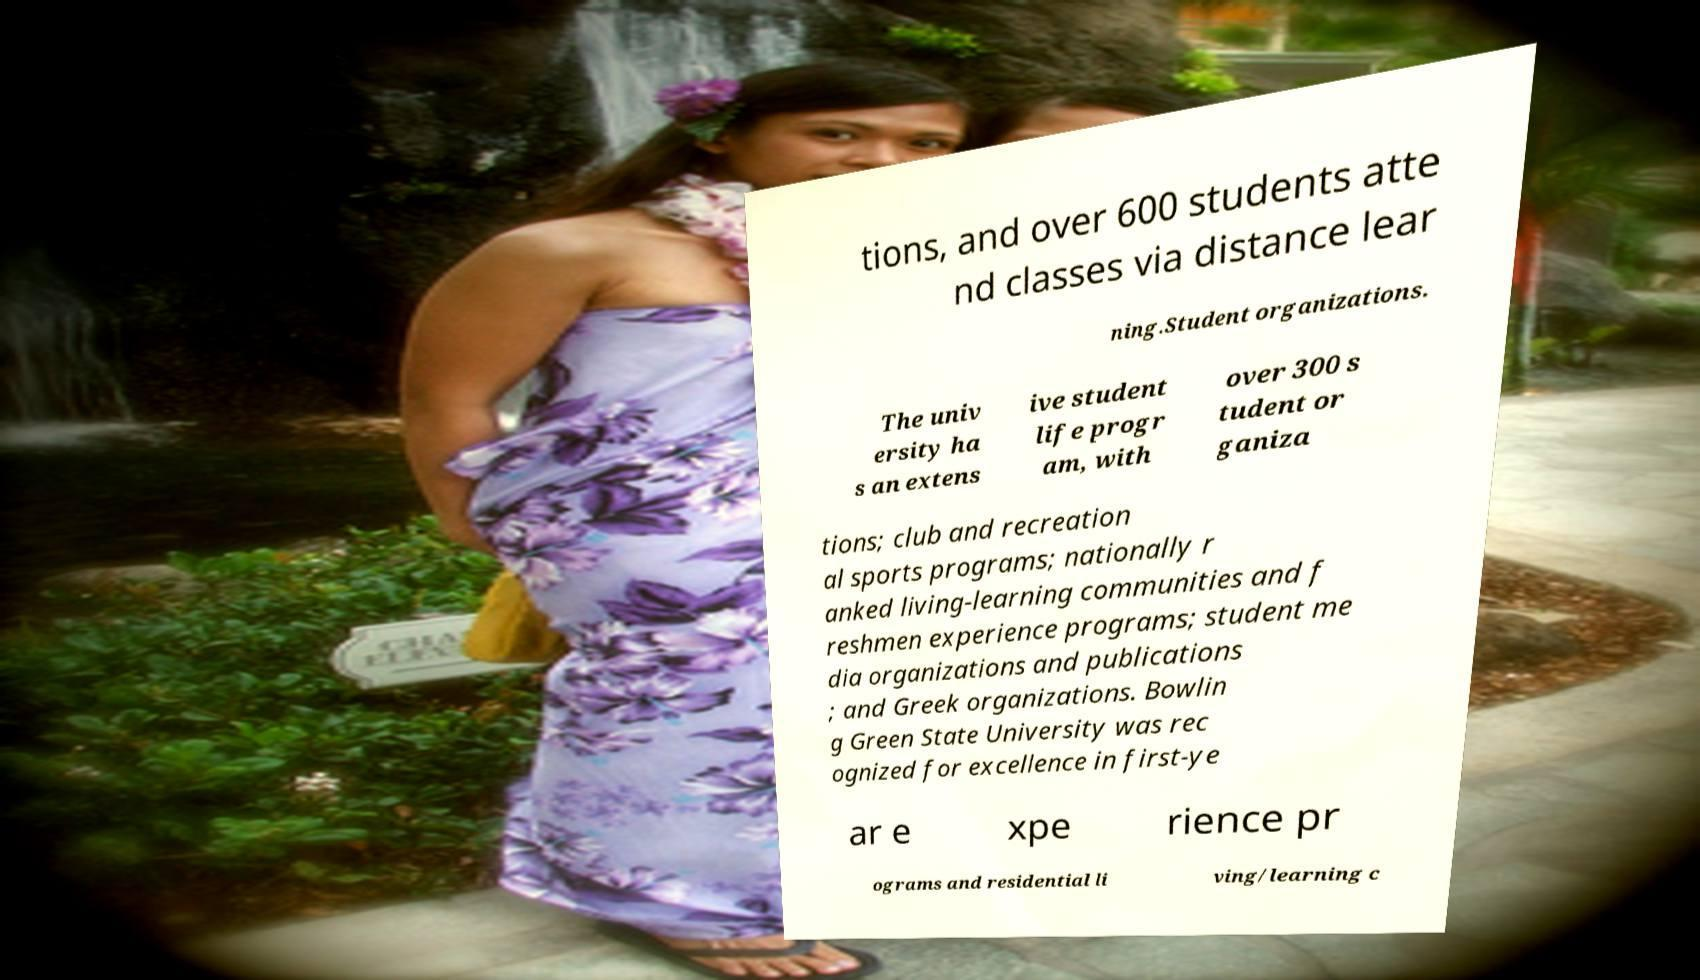Could you assist in decoding the text presented in this image and type it out clearly? tions, and over 600 students atte nd classes via distance lear ning.Student organizations. The univ ersity ha s an extens ive student life progr am, with over 300 s tudent or ganiza tions; club and recreation al sports programs; nationally r anked living-learning communities and f reshmen experience programs; student me dia organizations and publications ; and Greek organizations. Bowlin g Green State University was rec ognized for excellence in first-ye ar e xpe rience pr ograms and residential li ving/learning c 